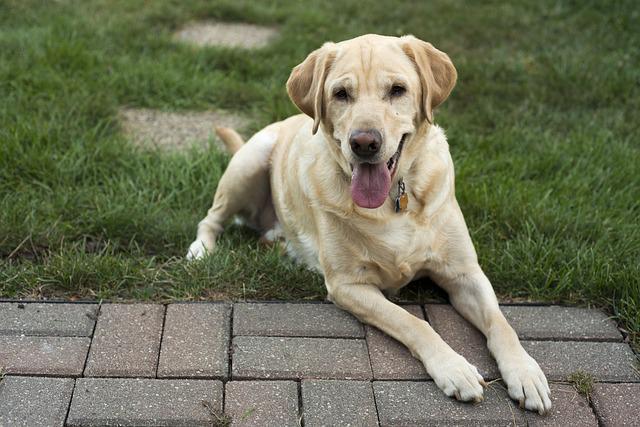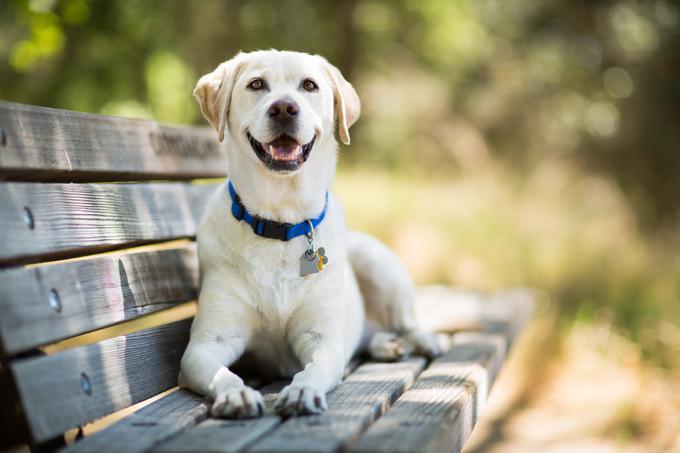The first image is the image on the left, the second image is the image on the right. Examine the images to the left and right. Is the description "There are two dogs" accurate? Answer yes or no. Yes. 